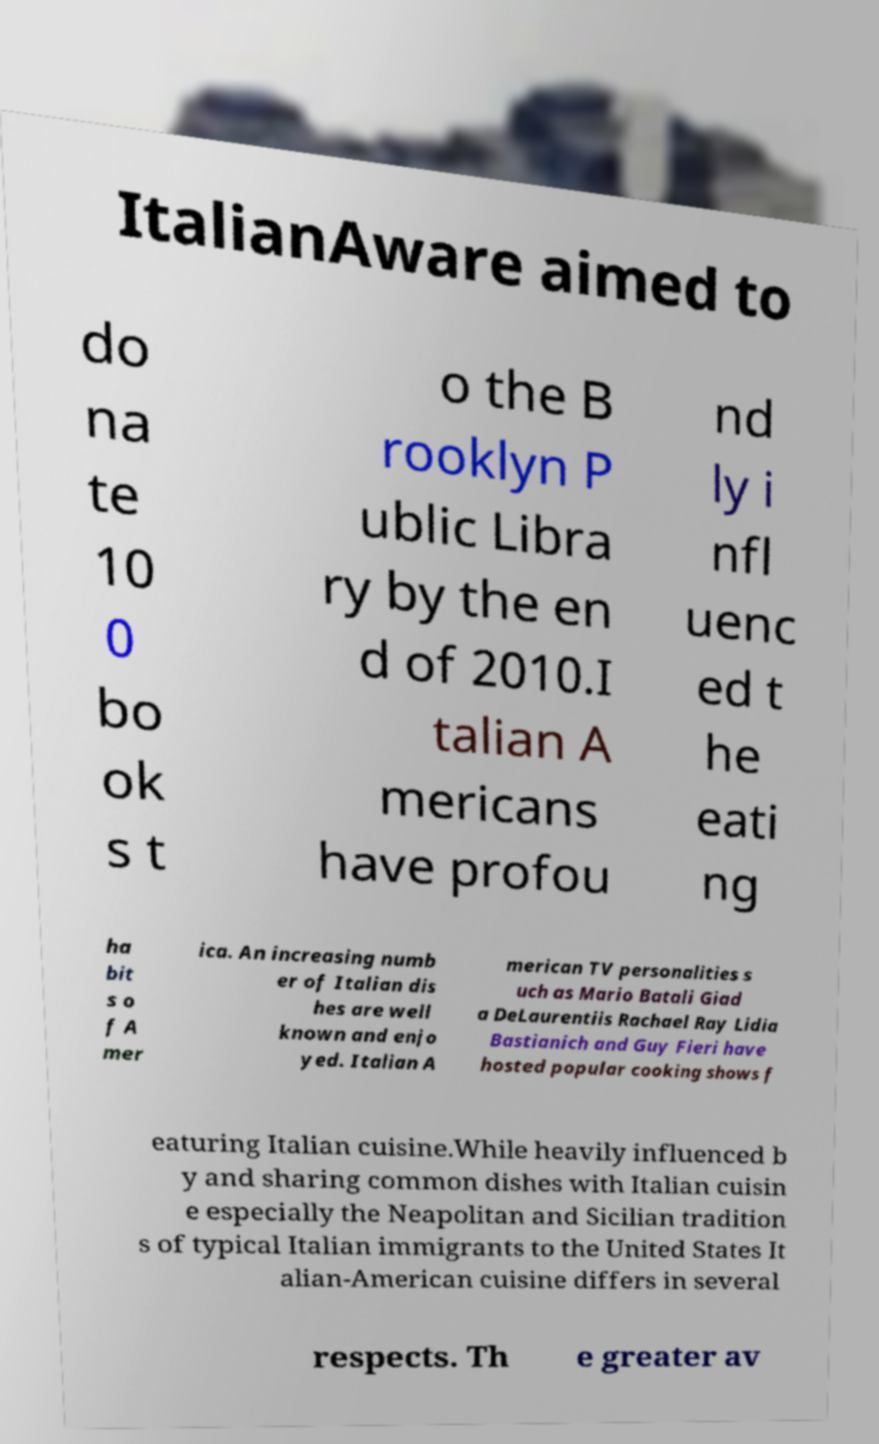Can you read and provide the text displayed in the image?This photo seems to have some interesting text. Can you extract and type it out for me? ItalianAware aimed to do na te 10 0 bo ok s t o the B rooklyn P ublic Libra ry by the en d of 2010.I talian A mericans have profou nd ly i nfl uenc ed t he eati ng ha bit s o f A mer ica. An increasing numb er of Italian dis hes are well known and enjo yed. Italian A merican TV personalities s uch as Mario Batali Giad a DeLaurentiis Rachael Ray Lidia Bastianich and Guy Fieri have hosted popular cooking shows f eaturing Italian cuisine.While heavily influenced b y and sharing common dishes with Italian cuisin e especially the Neapolitan and Sicilian tradition s of typical Italian immigrants to the United States It alian-American cuisine differs in several respects. Th e greater av 